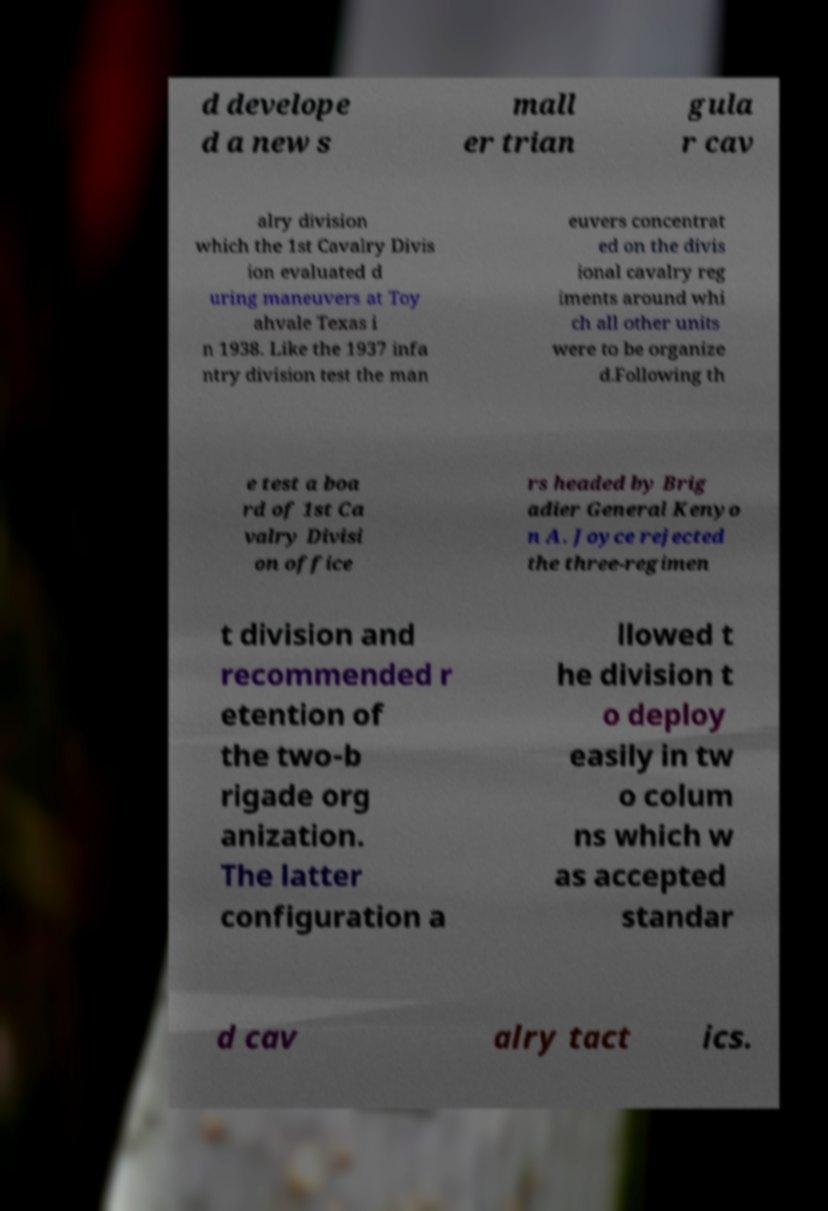What messages or text are displayed in this image? I need them in a readable, typed format. d develope d a new s mall er trian gula r cav alry division which the 1st Cavalry Divis ion evaluated d uring maneuvers at Toy ahvale Texas i n 1938. Like the 1937 infa ntry division test the man euvers concentrat ed on the divis ional cavalry reg iments around whi ch all other units were to be organize d.Following th e test a boa rd of 1st Ca valry Divisi on office rs headed by Brig adier General Kenyo n A. Joyce rejected the three-regimen t division and recommended r etention of the two-b rigade org anization. The latter configuration a llowed t he division t o deploy easily in tw o colum ns which w as accepted standar d cav alry tact ics. 